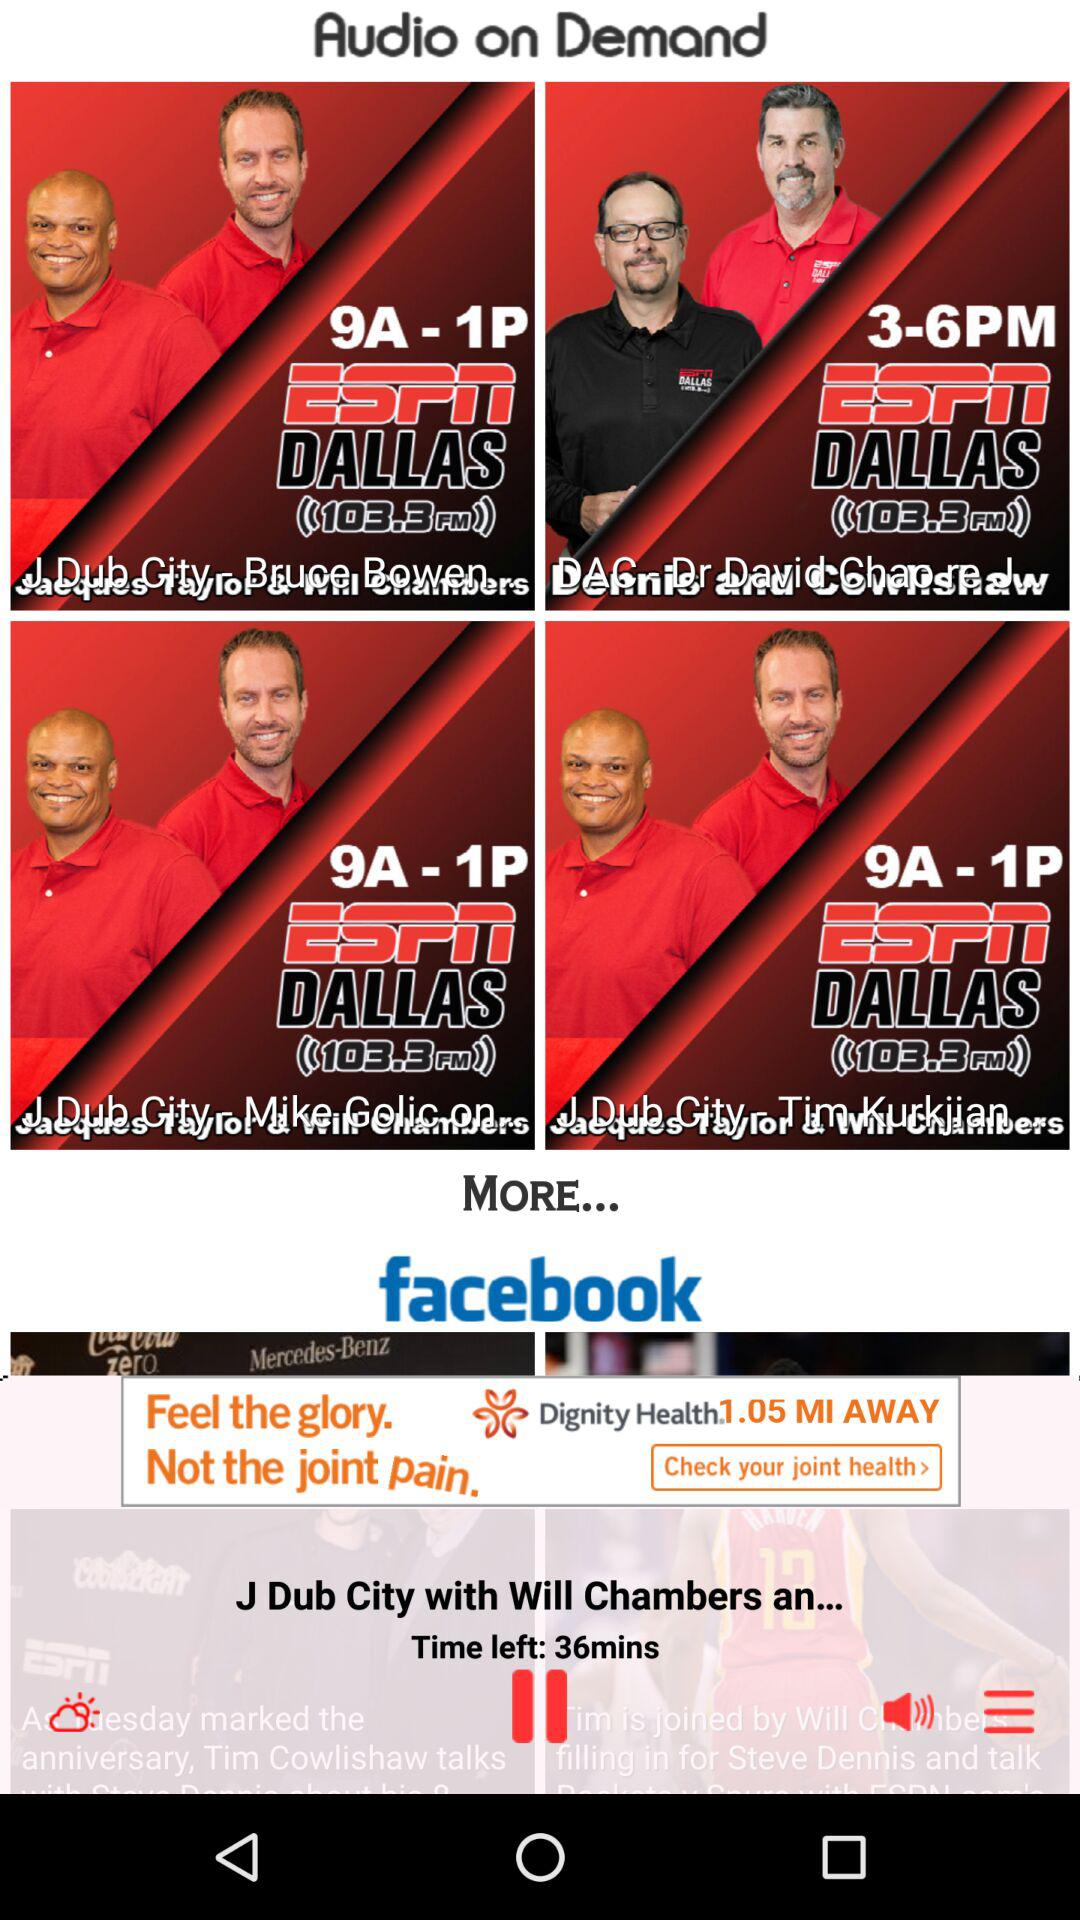How much time is left? There are 36 minutes left. 